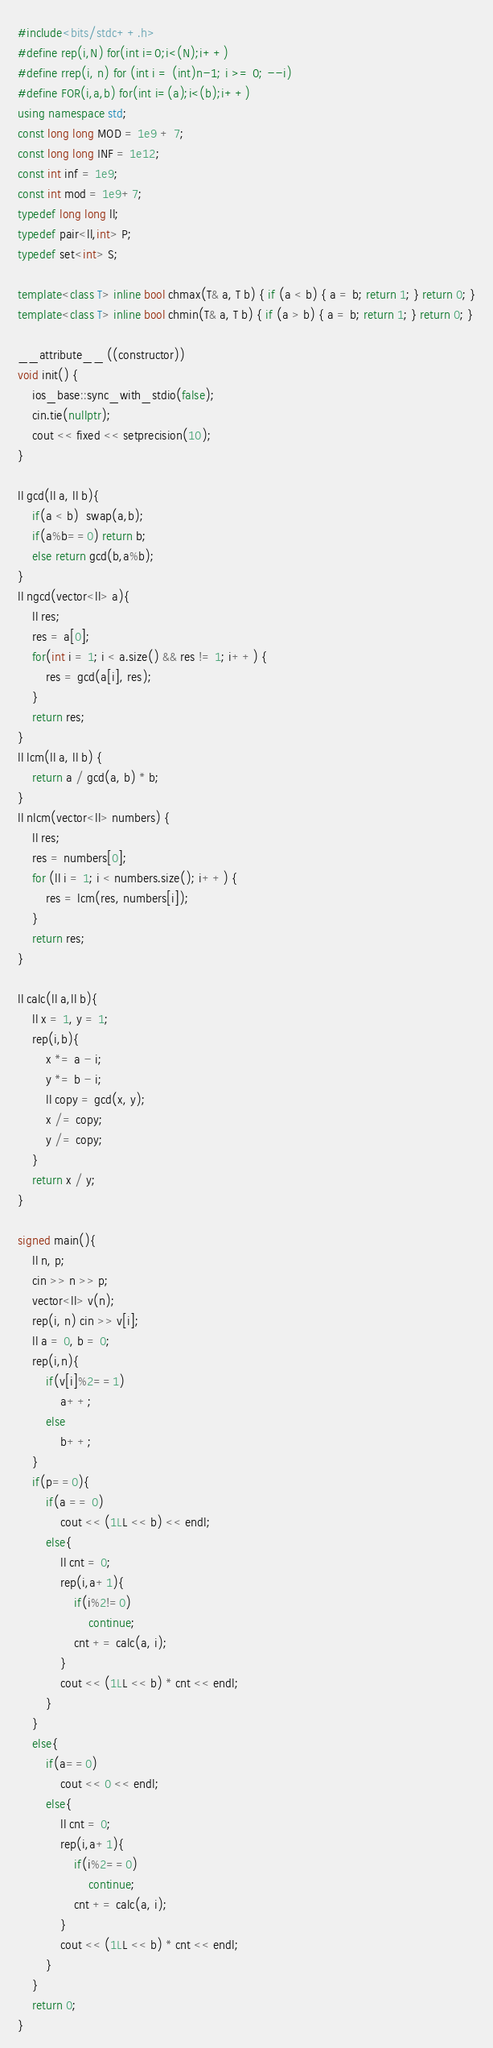<code> <loc_0><loc_0><loc_500><loc_500><_C++_>#include<bits/stdc++.h>
#define rep(i,N) for(int i=0;i<(N);i++)
#define rrep(i, n) for (int i = (int)n-1; i >= 0; --i)
#define FOR(i,a,b) for(int i=(a);i<(b);i++)
using namespace std;
const long long MOD = 1e9 + 7;
const long long INF = 1e12;
const int inf = 1e9;
const int mod = 1e9+7;
typedef long long ll;
typedef pair<ll,int> P;
typedef set<int> S;

template<class T> inline bool chmax(T& a, T b) { if (a < b) { a = b; return 1; } return 0; }
template<class T> inline bool chmin(T& a, T b) { if (a > b) { a = b; return 1; } return 0; }

__attribute__ ((constructor))
void init() {
    ios_base::sync_with_stdio(false);
    cin.tie(nullptr);
    cout << fixed << setprecision(10);
}

ll gcd(ll a, ll b){
    if(a < b)  swap(a,b);
    if(a%b==0) return b;
    else return gcd(b,a%b);
}
ll ngcd(vector<ll> a){
    ll res;
    res = a[0];
    for(int i = 1; i < a.size() && res != 1; i++) {
        res = gcd(a[i], res);
    }
    return res;
}
ll lcm(ll a, ll b) {
    return a / gcd(a, b) * b;
}
ll nlcm(vector<ll> numbers) {
    ll res;
    res = numbers[0];
    for (ll i = 1; i < numbers.size(); i++) {
        res = lcm(res, numbers[i]);
    }
    return res;
}

ll calc(ll a,ll b){
    ll x = 1, y = 1;
    rep(i,b){
        x *= a - i;
        y *= b - i;
        ll copy = gcd(x, y);
        x /= copy;
        y /= copy;
    }
    return x / y;
}

signed main(){
    ll n, p;
    cin >> n >> p;
    vector<ll> v(n);
    rep(i, n) cin >> v[i];
    ll a = 0, b = 0;
    rep(i,n){
        if(v[i]%2==1)
            a++;
        else
            b++;
    }
    if(p==0){
        if(a == 0)
            cout << (1LL << b) << endl;
        else{
            ll cnt = 0;
            rep(i,a+1){
                if(i%2!=0)
                    continue;
                cnt += calc(a, i);
            }
            cout << (1LL << b) * cnt << endl;
        }
    }
    else{
        if(a==0)
            cout << 0 << endl;
        else{
            ll cnt = 0;
            rep(i,a+1){
                if(i%2==0)
                    continue;
                cnt += calc(a, i);
            }
            cout << (1LL << b) * cnt << endl;
        }
    }
    return 0;
}</code> 